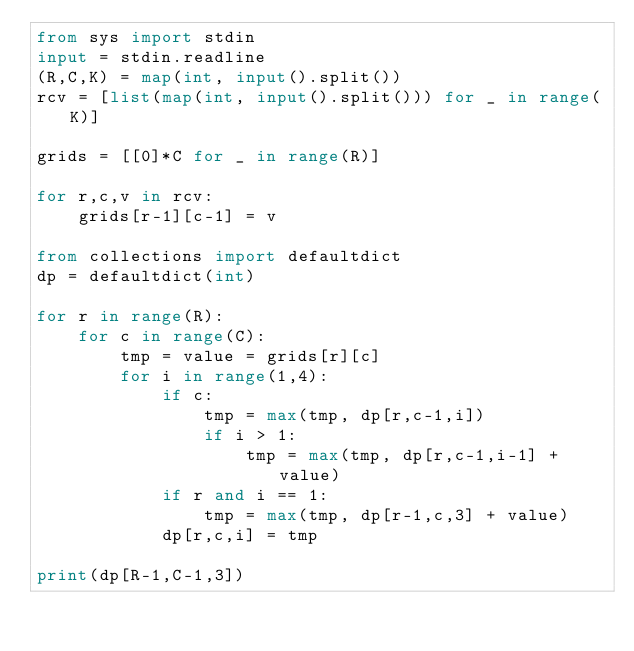<code> <loc_0><loc_0><loc_500><loc_500><_Python_>from sys import stdin
input = stdin.readline
(R,C,K) = map(int, input().split())
rcv = [list(map(int, input().split())) for _ in range(K)]

grids = [[0]*C for _ in range(R)]

for r,c,v in rcv:
    grids[r-1][c-1] = v

from collections import defaultdict
dp = defaultdict(int)

for r in range(R):
    for c in range(C):
        tmp = value = grids[r][c]
        for i in range(1,4):
            if c:
                tmp = max(tmp, dp[r,c-1,i])
                if i > 1:
                    tmp = max(tmp, dp[r,c-1,i-1] + value)
            if r and i == 1:
                tmp = max(tmp, dp[r-1,c,3] + value)
            dp[r,c,i] = tmp

print(dp[R-1,C-1,3])</code> 